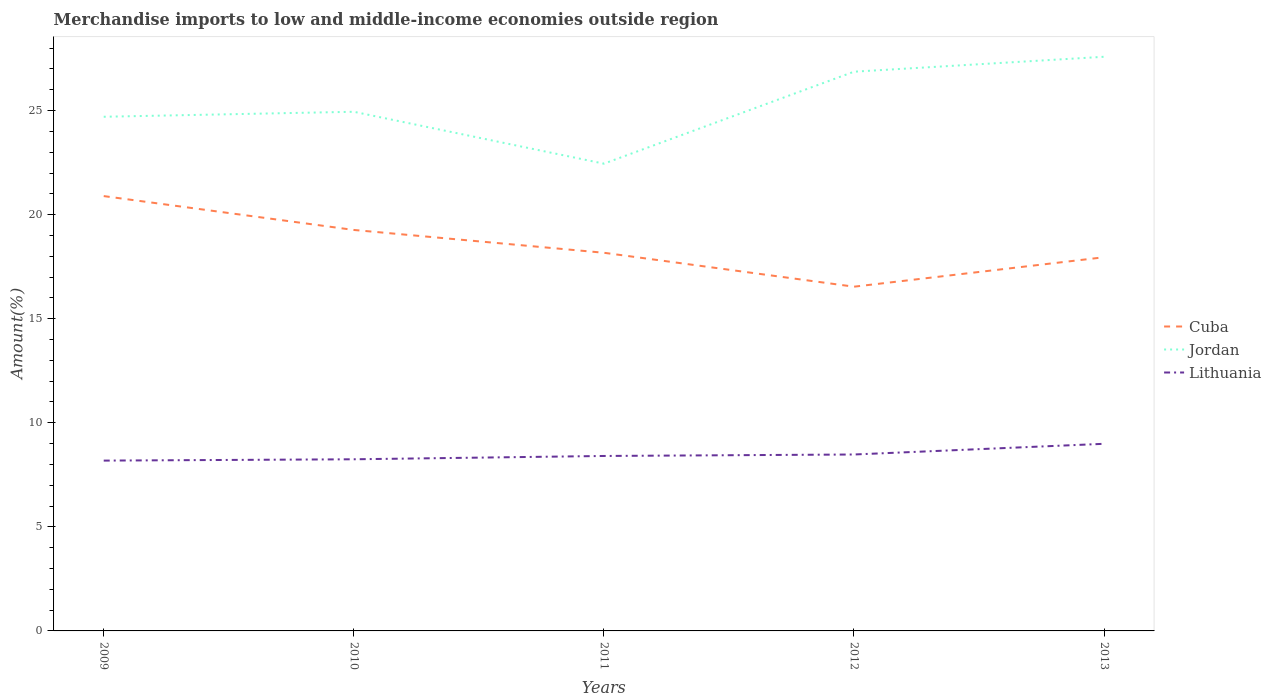Across all years, what is the maximum percentage of amount earned from merchandise imports in Cuba?
Ensure brevity in your answer.  16.54. What is the total percentage of amount earned from merchandise imports in Cuba in the graph?
Your answer should be very brief. 2.94. What is the difference between the highest and the second highest percentage of amount earned from merchandise imports in Cuba?
Give a very brief answer. 4.35. How many lines are there?
Ensure brevity in your answer.  3. What is the difference between two consecutive major ticks on the Y-axis?
Provide a succinct answer. 5. Are the values on the major ticks of Y-axis written in scientific E-notation?
Offer a terse response. No. Where does the legend appear in the graph?
Offer a terse response. Center right. How are the legend labels stacked?
Keep it short and to the point. Vertical. What is the title of the graph?
Your answer should be compact. Merchandise imports to low and middle-income economies outside region. Does "Low & middle income" appear as one of the legend labels in the graph?
Ensure brevity in your answer.  No. What is the label or title of the X-axis?
Offer a very short reply. Years. What is the label or title of the Y-axis?
Offer a terse response. Amount(%). What is the Amount(%) in Cuba in 2009?
Offer a very short reply. 20.89. What is the Amount(%) of Jordan in 2009?
Keep it short and to the point. 24.7. What is the Amount(%) in Lithuania in 2009?
Provide a succinct answer. 8.18. What is the Amount(%) in Cuba in 2010?
Your answer should be compact. 19.27. What is the Amount(%) of Jordan in 2010?
Offer a terse response. 24.94. What is the Amount(%) in Lithuania in 2010?
Your response must be concise. 8.25. What is the Amount(%) of Cuba in 2011?
Keep it short and to the point. 18.17. What is the Amount(%) in Jordan in 2011?
Provide a short and direct response. 22.45. What is the Amount(%) of Lithuania in 2011?
Your answer should be very brief. 8.41. What is the Amount(%) of Cuba in 2012?
Ensure brevity in your answer.  16.54. What is the Amount(%) in Jordan in 2012?
Provide a succinct answer. 26.87. What is the Amount(%) of Lithuania in 2012?
Your answer should be very brief. 8.48. What is the Amount(%) in Cuba in 2013?
Provide a succinct answer. 17.95. What is the Amount(%) in Jordan in 2013?
Your answer should be compact. 27.59. What is the Amount(%) in Lithuania in 2013?
Keep it short and to the point. 8.99. Across all years, what is the maximum Amount(%) in Cuba?
Provide a succinct answer. 20.89. Across all years, what is the maximum Amount(%) in Jordan?
Offer a very short reply. 27.59. Across all years, what is the maximum Amount(%) of Lithuania?
Offer a very short reply. 8.99. Across all years, what is the minimum Amount(%) in Cuba?
Offer a terse response. 16.54. Across all years, what is the minimum Amount(%) of Jordan?
Ensure brevity in your answer.  22.45. Across all years, what is the minimum Amount(%) of Lithuania?
Your response must be concise. 8.18. What is the total Amount(%) in Cuba in the graph?
Keep it short and to the point. 92.82. What is the total Amount(%) in Jordan in the graph?
Make the answer very short. 126.55. What is the total Amount(%) in Lithuania in the graph?
Offer a terse response. 42.3. What is the difference between the Amount(%) in Cuba in 2009 and that in 2010?
Offer a terse response. 1.63. What is the difference between the Amount(%) in Jordan in 2009 and that in 2010?
Provide a succinct answer. -0.24. What is the difference between the Amount(%) in Lithuania in 2009 and that in 2010?
Offer a terse response. -0.06. What is the difference between the Amount(%) in Cuba in 2009 and that in 2011?
Give a very brief answer. 2.72. What is the difference between the Amount(%) of Jordan in 2009 and that in 2011?
Offer a very short reply. 2.25. What is the difference between the Amount(%) in Lithuania in 2009 and that in 2011?
Your answer should be compact. -0.22. What is the difference between the Amount(%) of Cuba in 2009 and that in 2012?
Offer a very short reply. 4.35. What is the difference between the Amount(%) in Jordan in 2009 and that in 2012?
Ensure brevity in your answer.  -2.17. What is the difference between the Amount(%) of Lithuania in 2009 and that in 2012?
Your answer should be very brief. -0.29. What is the difference between the Amount(%) of Cuba in 2009 and that in 2013?
Offer a very short reply. 2.94. What is the difference between the Amount(%) in Jordan in 2009 and that in 2013?
Your answer should be very brief. -2.88. What is the difference between the Amount(%) in Lithuania in 2009 and that in 2013?
Keep it short and to the point. -0.81. What is the difference between the Amount(%) in Cuba in 2010 and that in 2011?
Your answer should be very brief. 1.1. What is the difference between the Amount(%) in Jordan in 2010 and that in 2011?
Ensure brevity in your answer.  2.49. What is the difference between the Amount(%) in Lithuania in 2010 and that in 2011?
Keep it short and to the point. -0.16. What is the difference between the Amount(%) in Cuba in 2010 and that in 2012?
Your answer should be compact. 2.73. What is the difference between the Amount(%) of Jordan in 2010 and that in 2012?
Ensure brevity in your answer.  -1.93. What is the difference between the Amount(%) in Lithuania in 2010 and that in 2012?
Provide a succinct answer. -0.23. What is the difference between the Amount(%) in Cuba in 2010 and that in 2013?
Provide a succinct answer. 1.31. What is the difference between the Amount(%) in Jordan in 2010 and that in 2013?
Keep it short and to the point. -2.64. What is the difference between the Amount(%) of Lithuania in 2010 and that in 2013?
Ensure brevity in your answer.  -0.74. What is the difference between the Amount(%) in Cuba in 2011 and that in 2012?
Ensure brevity in your answer.  1.63. What is the difference between the Amount(%) of Jordan in 2011 and that in 2012?
Ensure brevity in your answer.  -4.42. What is the difference between the Amount(%) of Lithuania in 2011 and that in 2012?
Your response must be concise. -0.07. What is the difference between the Amount(%) of Cuba in 2011 and that in 2013?
Make the answer very short. 0.21. What is the difference between the Amount(%) of Jordan in 2011 and that in 2013?
Ensure brevity in your answer.  -5.14. What is the difference between the Amount(%) in Lithuania in 2011 and that in 2013?
Give a very brief answer. -0.58. What is the difference between the Amount(%) of Cuba in 2012 and that in 2013?
Offer a very short reply. -1.42. What is the difference between the Amount(%) of Jordan in 2012 and that in 2013?
Provide a short and direct response. -0.72. What is the difference between the Amount(%) of Lithuania in 2012 and that in 2013?
Provide a short and direct response. -0.51. What is the difference between the Amount(%) in Cuba in 2009 and the Amount(%) in Jordan in 2010?
Offer a terse response. -4.05. What is the difference between the Amount(%) in Cuba in 2009 and the Amount(%) in Lithuania in 2010?
Give a very brief answer. 12.65. What is the difference between the Amount(%) of Jordan in 2009 and the Amount(%) of Lithuania in 2010?
Provide a short and direct response. 16.46. What is the difference between the Amount(%) in Cuba in 2009 and the Amount(%) in Jordan in 2011?
Make the answer very short. -1.56. What is the difference between the Amount(%) of Cuba in 2009 and the Amount(%) of Lithuania in 2011?
Make the answer very short. 12.49. What is the difference between the Amount(%) of Jordan in 2009 and the Amount(%) of Lithuania in 2011?
Provide a succinct answer. 16.3. What is the difference between the Amount(%) of Cuba in 2009 and the Amount(%) of Jordan in 2012?
Offer a terse response. -5.98. What is the difference between the Amount(%) in Cuba in 2009 and the Amount(%) in Lithuania in 2012?
Provide a short and direct response. 12.42. What is the difference between the Amount(%) of Jordan in 2009 and the Amount(%) of Lithuania in 2012?
Offer a terse response. 16.23. What is the difference between the Amount(%) of Cuba in 2009 and the Amount(%) of Jordan in 2013?
Your answer should be compact. -6.69. What is the difference between the Amount(%) of Cuba in 2009 and the Amount(%) of Lithuania in 2013?
Make the answer very short. 11.9. What is the difference between the Amount(%) in Jordan in 2009 and the Amount(%) in Lithuania in 2013?
Give a very brief answer. 15.71. What is the difference between the Amount(%) in Cuba in 2010 and the Amount(%) in Jordan in 2011?
Provide a succinct answer. -3.18. What is the difference between the Amount(%) of Cuba in 2010 and the Amount(%) of Lithuania in 2011?
Your answer should be compact. 10.86. What is the difference between the Amount(%) in Jordan in 2010 and the Amount(%) in Lithuania in 2011?
Ensure brevity in your answer.  16.54. What is the difference between the Amount(%) in Cuba in 2010 and the Amount(%) in Jordan in 2012?
Ensure brevity in your answer.  -7.6. What is the difference between the Amount(%) of Cuba in 2010 and the Amount(%) of Lithuania in 2012?
Give a very brief answer. 10.79. What is the difference between the Amount(%) of Jordan in 2010 and the Amount(%) of Lithuania in 2012?
Your response must be concise. 16.47. What is the difference between the Amount(%) in Cuba in 2010 and the Amount(%) in Jordan in 2013?
Offer a terse response. -8.32. What is the difference between the Amount(%) of Cuba in 2010 and the Amount(%) of Lithuania in 2013?
Provide a succinct answer. 10.27. What is the difference between the Amount(%) in Jordan in 2010 and the Amount(%) in Lithuania in 2013?
Keep it short and to the point. 15.95. What is the difference between the Amount(%) of Cuba in 2011 and the Amount(%) of Jordan in 2012?
Your answer should be compact. -8.7. What is the difference between the Amount(%) in Cuba in 2011 and the Amount(%) in Lithuania in 2012?
Offer a very short reply. 9.69. What is the difference between the Amount(%) of Jordan in 2011 and the Amount(%) of Lithuania in 2012?
Offer a terse response. 13.97. What is the difference between the Amount(%) in Cuba in 2011 and the Amount(%) in Jordan in 2013?
Provide a succinct answer. -9.42. What is the difference between the Amount(%) in Cuba in 2011 and the Amount(%) in Lithuania in 2013?
Your response must be concise. 9.18. What is the difference between the Amount(%) in Jordan in 2011 and the Amount(%) in Lithuania in 2013?
Your response must be concise. 13.46. What is the difference between the Amount(%) of Cuba in 2012 and the Amount(%) of Jordan in 2013?
Offer a terse response. -11.05. What is the difference between the Amount(%) in Cuba in 2012 and the Amount(%) in Lithuania in 2013?
Make the answer very short. 7.55. What is the difference between the Amount(%) of Jordan in 2012 and the Amount(%) of Lithuania in 2013?
Keep it short and to the point. 17.88. What is the average Amount(%) of Cuba per year?
Offer a terse response. 18.56. What is the average Amount(%) of Jordan per year?
Provide a succinct answer. 25.31. What is the average Amount(%) in Lithuania per year?
Provide a succinct answer. 8.46. In the year 2009, what is the difference between the Amount(%) in Cuba and Amount(%) in Jordan?
Ensure brevity in your answer.  -3.81. In the year 2009, what is the difference between the Amount(%) of Cuba and Amount(%) of Lithuania?
Provide a succinct answer. 12.71. In the year 2009, what is the difference between the Amount(%) in Jordan and Amount(%) in Lithuania?
Provide a short and direct response. 16.52. In the year 2010, what is the difference between the Amount(%) in Cuba and Amount(%) in Jordan?
Offer a very short reply. -5.68. In the year 2010, what is the difference between the Amount(%) of Cuba and Amount(%) of Lithuania?
Your response must be concise. 11.02. In the year 2010, what is the difference between the Amount(%) of Jordan and Amount(%) of Lithuania?
Keep it short and to the point. 16.7. In the year 2011, what is the difference between the Amount(%) in Cuba and Amount(%) in Jordan?
Your answer should be very brief. -4.28. In the year 2011, what is the difference between the Amount(%) in Cuba and Amount(%) in Lithuania?
Your answer should be very brief. 9.76. In the year 2011, what is the difference between the Amount(%) of Jordan and Amount(%) of Lithuania?
Ensure brevity in your answer.  14.04. In the year 2012, what is the difference between the Amount(%) of Cuba and Amount(%) of Jordan?
Ensure brevity in your answer.  -10.33. In the year 2012, what is the difference between the Amount(%) in Cuba and Amount(%) in Lithuania?
Keep it short and to the point. 8.06. In the year 2012, what is the difference between the Amount(%) of Jordan and Amount(%) of Lithuania?
Your answer should be compact. 18.39. In the year 2013, what is the difference between the Amount(%) of Cuba and Amount(%) of Jordan?
Keep it short and to the point. -9.63. In the year 2013, what is the difference between the Amount(%) in Cuba and Amount(%) in Lithuania?
Ensure brevity in your answer.  8.96. In the year 2013, what is the difference between the Amount(%) of Jordan and Amount(%) of Lithuania?
Your answer should be compact. 18.6. What is the ratio of the Amount(%) in Cuba in 2009 to that in 2010?
Your answer should be very brief. 1.08. What is the ratio of the Amount(%) in Jordan in 2009 to that in 2010?
Offer a terse response. 0.99. What is the ratio of the Amount(%) in Lithuania in 2009 to that in 2010?
Give a very brief answer. 0.99. What is the ratio of the Amount(%) in Cuba in 2009 to that in 2011?
Give a very brief answer. 1.15. What is the ratio of the Amount(%) of Jordan in 2009 to that in 2011?
Your answer should be very brief. 1.1. What is the ratio of the Amount(%) in Lithuania in 2009 to that in 2011?
Provide a succinct answer. 0.97. What is the ratio of the Amount(%) in Cuba in 2009 to that in 2012?
Give a very brief answer. 1.26. What is the ratio of the Amount(%) of Jordan in 2009 to that in 2012?
Provide a short and direct response. 0.92. What is the ratio of the Amount(%) of Lithuania in 2009 to that in 2012?
Offer a very short reply. 0.97. What is the ratio of the Amount(%) in Cuba in 2009 to that in 2013?
Make the answer very short. 1.16. What is the ratio of the Amount(%) of Jordan in 2009 to that in 2013?
Give a very brief answer. 0.9. What is the ratio of the Amount(%) of Lithuania in 2009 to that in 2013?
Provide a succinct answer. 0.91. What is the ratio of the Amount(%) of Cuba in 2010 to that in 2011?
Your answer should be very brief. 1.06. What is the ratio of the Amount(%) in Jordan in 2010 to that in 2011?
Your answer should be compact. 1.11. What is the ratio of the Amount(%) in Lithuania in 2010 to that in 2011?
Provide a short and direct response. 0.98. What is the ratio of the Amount(%) of Cuba in 2010 to that in 2012?
Ensure brevity in your answer.  1.16. What is the ratio of the Amount(%) in Jordan in 2010 to that in 2012?
Offer a very short reply. 0.93. What is the ratio of the Amount(%) of Lithuania in 2010 to that in 2012?
Make the answer very short. 0.97. What is the ratio of the Amount(%) of Cuba in 2010 to that in 2013?
Your response must be concise. 1.07. What is the ratio of the Amount(%) in Jordan in 2010 to that in 2013?
Make the answer very short. 0.9. What is the ratio of the Amount(%) of Lithuania in 2010 to that in 2013?
Your answer should be compact. 0.92. What is the ratio of the Amount(%) in Cuba in 2011 to that in 2012?
Offer a terse response. 1.1. What is the ratio of the Amount(%) of Jordan in 2011 to that in 2012?
Ensure brevity in your answer.  0.84. What is the ratio of the Amount(%) in Cuba in 2011 to that in 2013?
Your response must be concise. 1.01. What is the ratio of the Amount(%) of Jordan in 2011 to that in 2013?
Your response must be concise. 0.81. What is the ratio of the Amount(%) of Lithuania in 2011 to that in 2013?
Your response must be concise. 0.94. What is the ratio of the Amount(%) of Cuba in 2012 to that in 2013?
Provide a succinct answer. 0.92. What is the ratio of the Amount(%) in Lithuania in 2012 to that in 2013?
Make the answer very short. 0.94. What is the difference between the highest and the second highest Amount(%) in Cuba?
Make the answer very short. 1.63. What is the difference between the highest and the second highest Amount(%) in Jordan?
Keep it short and to the point. 0.72. What is the difference between the highest and the second highest Amount(%) of Lithuania?
Give a very brief answer. 0.51. What is the difference between the highest and the lowest Amount(%) of Cuba?
Keep it short and to the point. 4.35. What is the difference between the highest and the lowest Amount(%) in Jordan?
Give a very brief answer. 5.14. What is the difference between the highest and the lowest Amount(%) in Lithuania?
Your answer should be very brief. 0.81. 